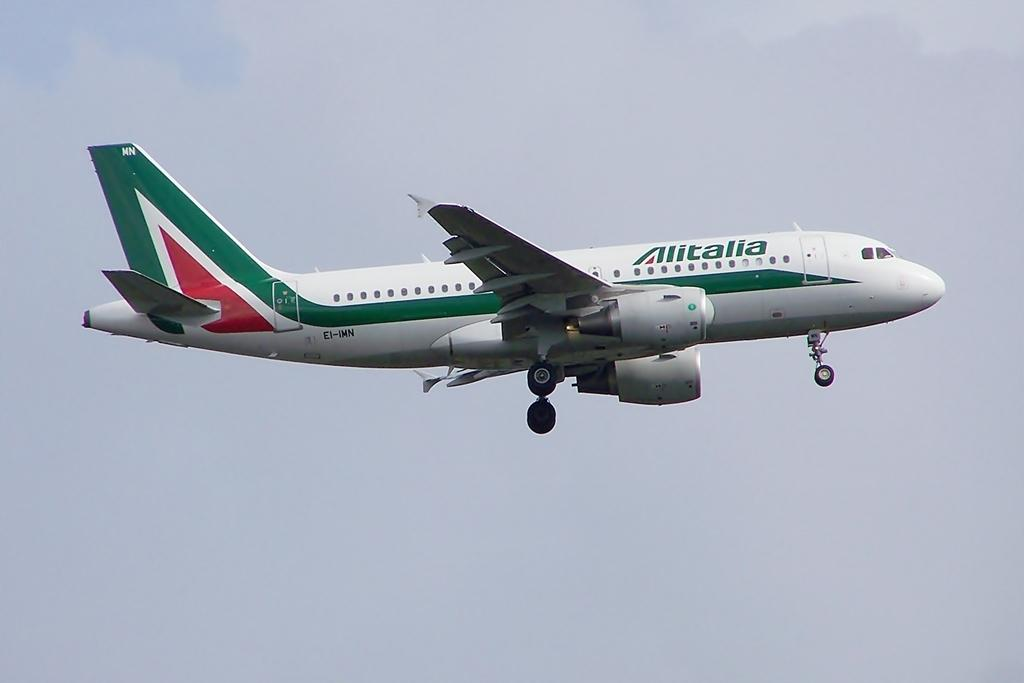<image>
Give a short and clear explanation of the subsequent image. landing gears down on white airliner with green stripe and Alitalia in green lettering 